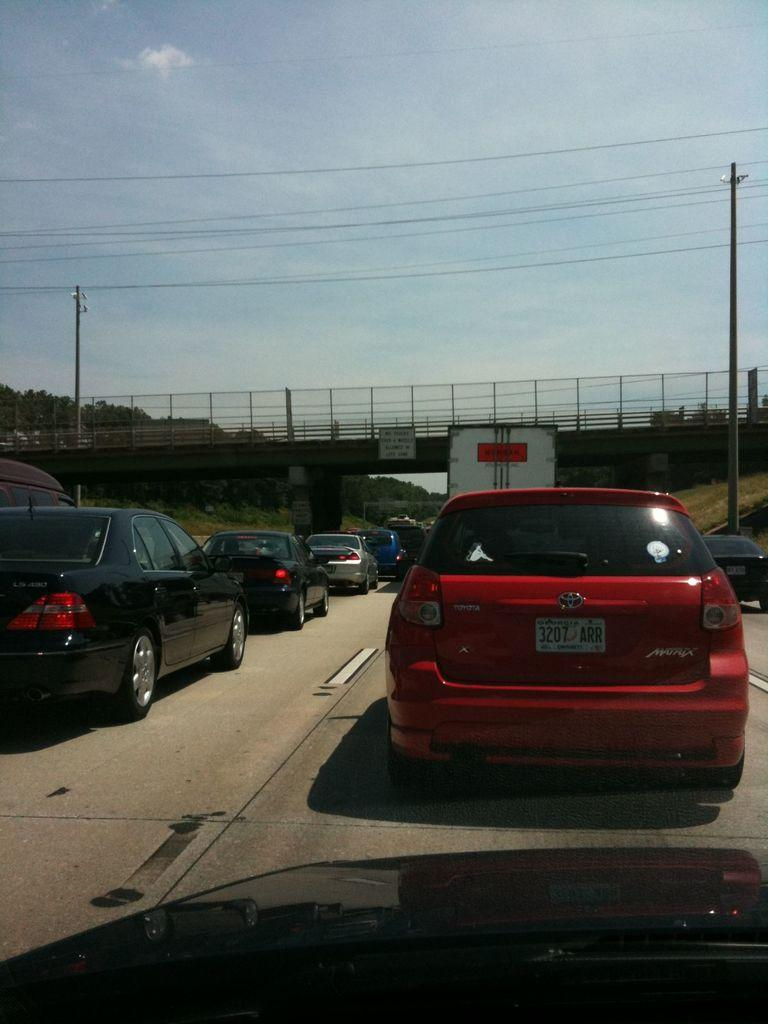What can be seen on the road in the image? There are cars on the road in the image. What is located in the background of the image? There is a bridge, poles, and trees in the background of the image. What is visible at the top of the image? The sky is visible at the top of the image, and there are wires visible as well. Can you tell me how many aunts are walking down the alley in the image? There is no alley or aunt present in the image. What type of voyage is depicted in the image? There is no voyage depicted in the image; it features cars on a road with a bridge, poles, trees, and wires in the background. 